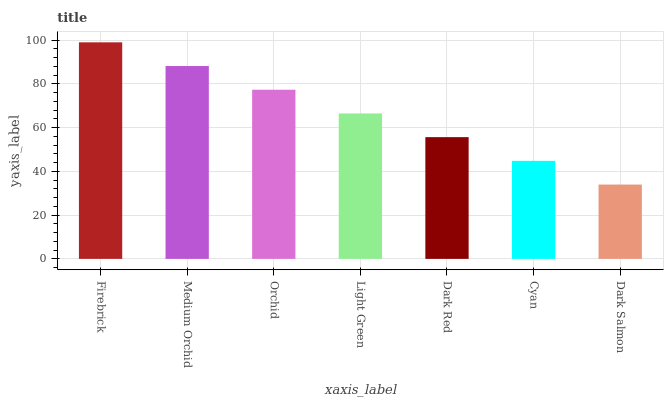Is Dark Salmon the minimum?
Answer yes or no. Yes. Is Firebrick the maximum?
Answer yes or no. Yes. Is Medium Orchid the minimum?
Answer yes or no. No. Is Medium Orchid the maximum?
Answer yes or no. No. Is Firebrick greater than Medium Orchid?
Answer yes or no. Yes. Is Medium Orchid less than Firebrick?
Answer yes or no. Yes. Is Medium Orchid greater than Firebrick?
Answer yes or no. No. Is Firebrick less than Medium Orchid?
Answer yes or no. No. Is Light Green the high median?
Answer yes or no. Yes. Is Light Green the low median?
Answer yes or no. Yes. Is Firebrick the high median?
Answer yes or no. No. Is Dark Salmon the low median?
Answer yes or no. No. 